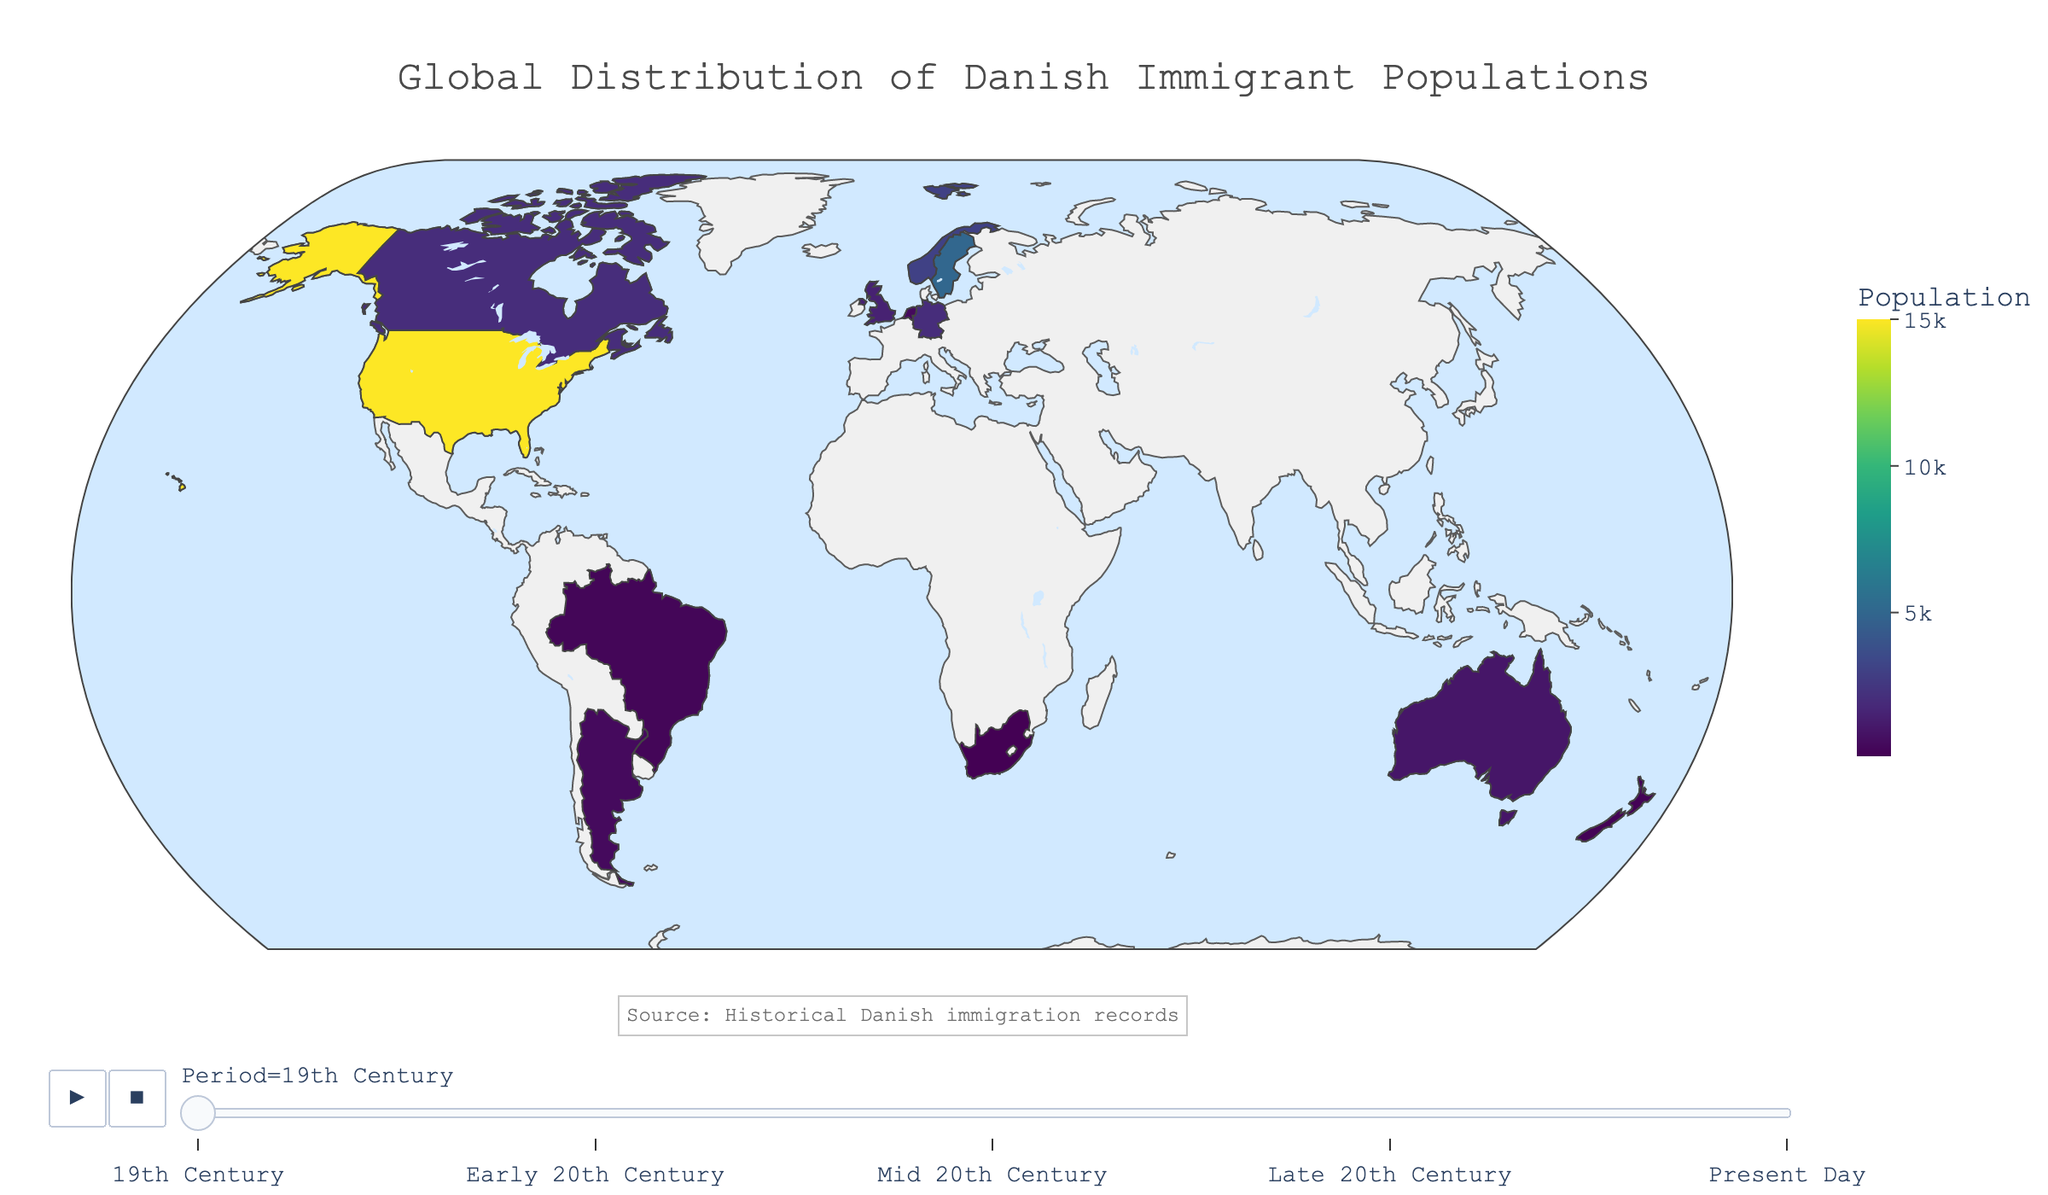How does the distribution of Danish immigrants change in the United States over time? The figure shows an increase in the population of Danish immigrants in the United States from 15,000 in the 19th century to 250,000 in the present day. This suggests a consistent growth through each of the periods represented on the plot.
Answer: Consistent increase In which country does the population of Danish immigrants grow the most from the mid-20th century to the present day? To determine this, subtract the mid-20th century population from the present-day population for each country. The United States saw growth from 150,000 to 250,000, the largest increase of 100,000.
Answer: United States Which period shows the most significant overall increase in Danish immigrant populations across all countries combined? To find this, look at the population values during each period and sum them. Compare the sums to determine in which period the greatest increase occurs. Summing for each period: 19th Century (29,600), Early 20th Century (152,000), Mid 20th Century (360,000), Late 20th Century (543,000), Present Day (743,000). The largest increase is from the mid-20th century to the late 20th century (543,000 - 360,000 = 183,000).
Answer: Late 20th Century Does South Africa show a significant increase in Danish immigrant populations over time? Check the population values for each period for South Africa. The values are 100, 1000, 3000, 5000, and 8000. The population increased but more modestly compared to other countries.
Answer: Modest increase Which country had Danish immigrant populations exactly equal during any two periods? Look at the population values for each period for every country. Argentina had populations of 5000 during both the early 20th century and early present day.
Answer: Argentina Compare the populations of Danish immigrants in Canada and Germany in the late 20th century. Which country had more? For the late 20th century period, compare the values for Canada (50,000) and Germany (35,000). Canada had a higher population of Danish immigrants.
Answer: Canada What is the average population of Danish immigrants in Argentina over the periods shown? To calculate the average, sum the populations of Argentina for each period and divide by the number of periods. (500+5000+15000+20000+25000) = 65500. Divide by 5: 65500 / 5 = 13100.
Answer: 13100 What trend is observed in Denmark's neighboring countries (Sweden and Norway) over time? Observe and compare the population values for Sweden and Norway over each period. Both show a steady increase: Sweden from 5000 to 80,000 and Norway from 3000 to 60,000. Both countries exhibit consistent growth in Danish immigrant populations.
Answer: Steady increase Which period had the smallest population growth for Danish immigrants in New Zealand? Examine the increase in populations between each period for New Zealand. The smallest growth was from the 19th century to the early 20th century (difference of 1800).
Answer: 19th Century to Early 20th Century 